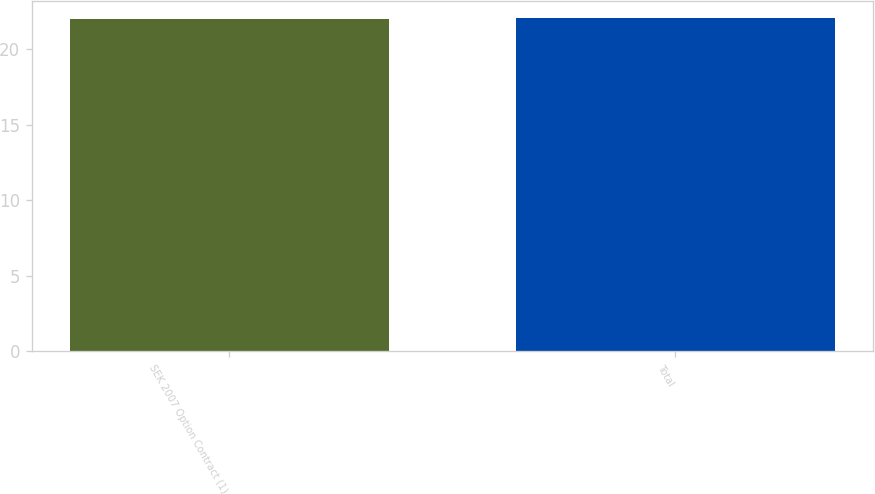Convert chart. <chart><loc_0><loc_0><loc_500><loc_500><bar_chart><fcel>SEK 2007 Option Contract (1)<fcel>Total<nl><fcel>22<fcel>22.1<nl></chart> 